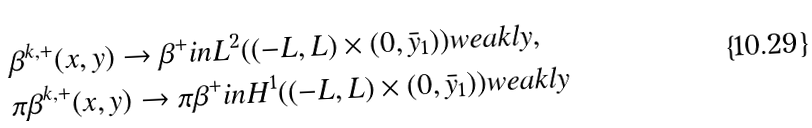Convert formula to latex. <formula><loc_0><loc_0><loc_500><loc_500>& \beta ^ { k , + } ( x , y ) \to \beta ^ { + } i n L ^ { 2 } ( ( - L , L ) \times ( 0 , \bar { y } _ { 1 } ) ) w e a k l y , \\ & \pi \beta ^ { k , + } ( x , y ) \to \pi \beta ^ { + } i n H ^ { 1 } ( ( - L , L ) \times ( 0 , \bar { y } _ { 1 } ) ) w e a k l y</formula> 